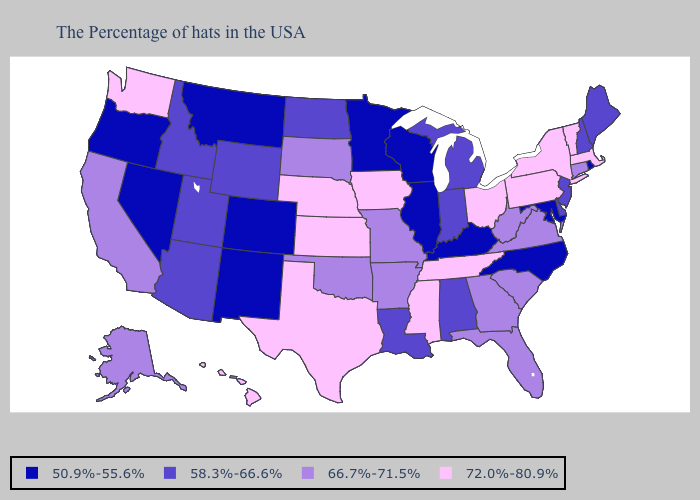What is the value of Wisconsin?
Keep it brief. 50.9%-55.6%. How many symbols are there in the legend?
Give a very brief answer. 4. Which states hav the highest value in the West?
Give a very brief answer. Washington, Hawaii. Name the states that have a value in the range 50.9%-55.6%?
Give a very brief answer. Rhode Island, Maryland, North Carolina, Kentucky, Wisconsin, Illinois, Minnesota, Colorado, New Mexico, Montana, Nevada, Oregon. What is the value of Delaware?
Give a very brief answer. 58.3%-66.6%. What is the value of Michigan?
Be succinct. 58.3%-66.6%. Does Idaho have a lower value than Colorado?
Concise answer only. No. What is the value of New York?
Write a very short answer. 72.0%-80.9%. Name the states that have a value in the range 58.3%-66.6%?
Short answer required. Maine, New Hampshire, New Jersey, Delaware, Michigan, Indiana, Alabama, Louisiana, North Dakota, Wyoming, Utah, Arizona, Idaho. Among the states that border Tennessee , does Mississippi have the highest value?
Give a very brief answer. Yes. Which states hav the highest value in the South?
Answer briefly. Tennessee, Mississippi, Texas. Among the states that border South Carolina , which have the lowest value?
Concise answer only. North Carolina. Does Pennsylvania have the highest value in the Northeast?
Keep it brief. Yes. Does the map have missing data?
Quick response, please. No. 